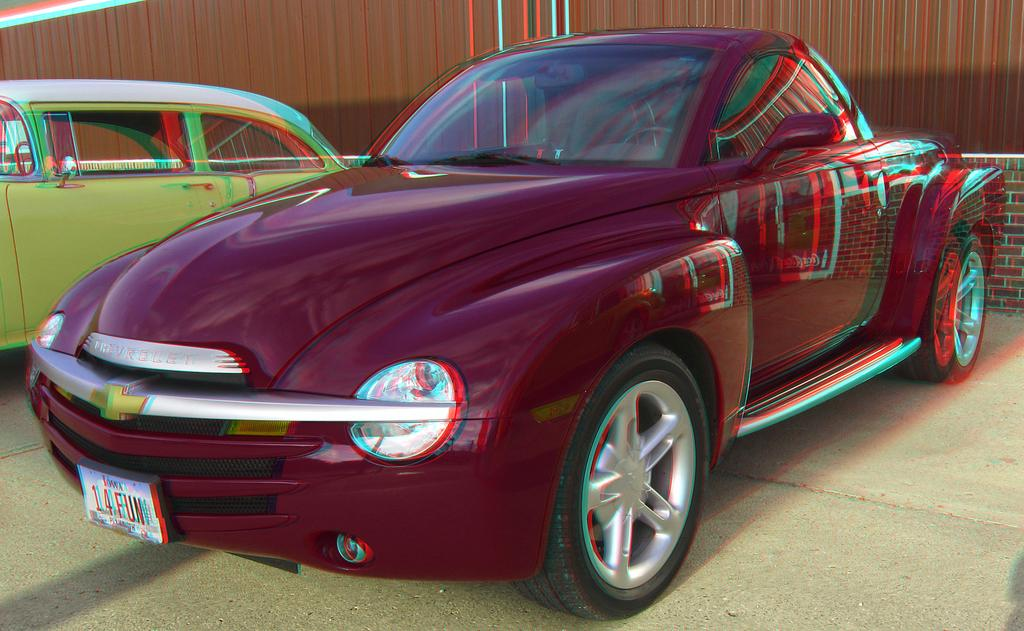How many car parks are visible in the image? There are two car parks visible in the image. Where is the first car park located? The first car park is at the front. Where is the second car park located? The second car park is at the back. What is the color of the back car park? The back car park is green in color. What is the color of the front car park? The front car park is maroon red in color. What type of cake is being served in the front car park? There is no cake present in the image; it features two car parks, one at the front and the other at the back. Are there any pests visible in the image? There is no mention of pests in the image, which only shows two car parks with different colors. 